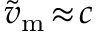Convert formula to latex. <formula><loc_0><loc_0><loc_500><loc_500>\widetilde { v } _ { m } \, \approx \, c</formula> 